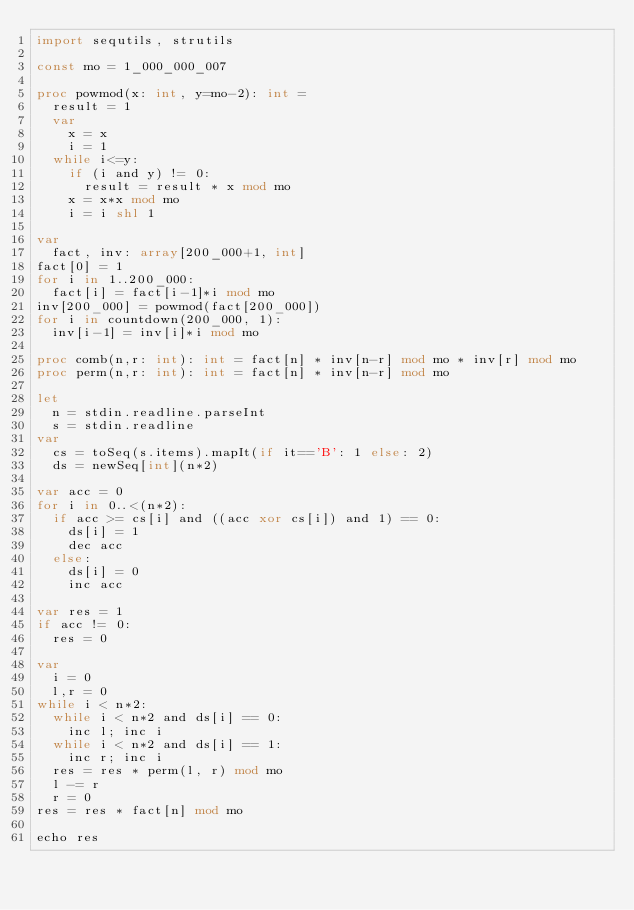<code> <loc_0><loc_0><loc_500><loc_500><_Nim_>import sequtils, strutils

const mo = 1_000_000_007

proc powmod(x: int, y=mo-2): int =
  result = 1
  var
    x = x
    i = 1
  while i<=y:
    if (i and y) != 0:
      result = result * x mod mo
    x = x*x mod mo
    i = i shl 1

var
  fact, inv: array[200_000+1, int]
fact[0] = 1
for i in 1..200_000:
  fact[i] = fact[i-1]*i mod mo
inv[200_000] = powmod(fact[200_000])
for i in countdown(200_000, 1):
  inv[i-1] = inv[i]*i mod mo

proc comb(n,r: int): int = fact[n] * inv[n-r] mod mo * inv[r] mod mo
proc perm(n,r: int): int = fact[n] * inv[n-r] mod mo

let
  n = stdin.readline.parseInt
  s = stdin.readline
var
  cs = toSeq(s.items).mapIt(if it=='B': 1 else: 2)
  ds = newSeq[int](n*2)

var acc = 0
for i in 0..<(n*2):
  if acc >= cs[i] and ((acc xor cs[i]) and 1) == 0:
    ds[i] = 1
    dec acc
  else:
    ds[i] = 0
    inc acc

var res = 1
if acc != 0:
  res = 0

var
  i = 0
  l,r = 0
while i < n*2:
  while i < n*2 and ds[i] == 0:
    inc l; inc i
  while i < n*2 and ds[i] == 1:
    inc r; inc i
  res = res * perm(l, r) mod mo
  l -= r
  r = 0
res = res * fact[n] mod mo

echo res
</code> 